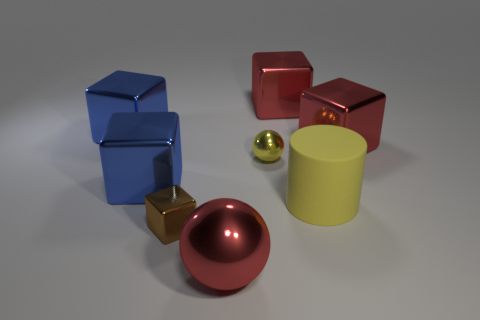Subtract all tiny brown metallic cubes. How many cubes are left? 4 Subtract all brown cubes. How many cubes are left? 4 Subtract all green cubes. Subtract all purple spheres. How many cubes are left? 5 Add 1 large yellow matte cylinders. How many objects exist? 9 Subtract all cylinders. How many objects are left? 7 Subtract all big blue shiny blocks. Subtract all large rubber cylinders. How many objects are left? 5 Add 7 tiny shiny objects. How many tiny shiny objects are left? 9 Add 1 large rubber objects. How many large rubber objects exist? 2 Subtract 0 gray cylinders. How many objects are left? 8 